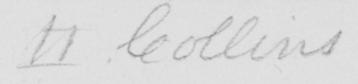Can you read and transcribe this handwriting? II Collins 